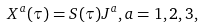<formula> <loc_0><loc_0><loc_500><loc_500>X ^ { a } ( \tau ) = S ( \tau ) J ^ { a } , a = 1 , 2 , 3 ,</formula> 